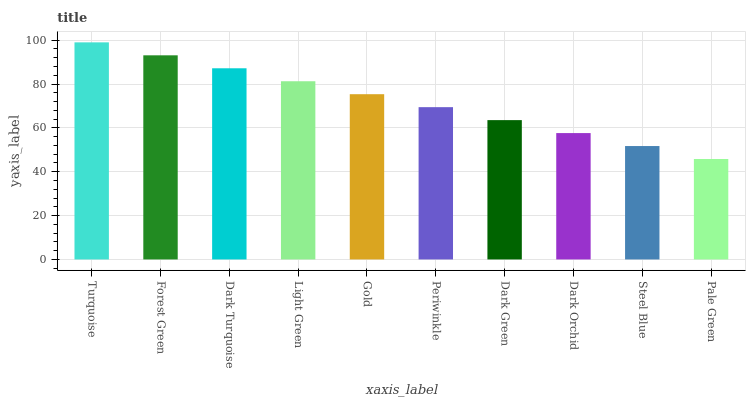Is Pale Green the minimum?
Answer yes or no. Yes. Is Turquoise the maximum?
Answer yes or no. Yes. Is Forest Green the minimum?
Answer yes or no. No. Is Forest Green the maximum?
Answer yes or no. No. Is Turquoise greater than Forest Green?
Answer yes or no. Yes. Is Forest Green less than Turquoise?
Answer yes or no. Yes. Is Forest Green greater than Turquoise?
Answer yes or no. No. Is Turquoise less than Forest Green?
Answer yes or no. No. Is Gold the high median?
Answer yes or no. Yes. Is Periwinkle the low median?
Answer yes or no. Yes. Is Light Green the high median?
Answer yes or no. No. Is Turquoise the low median?
Answer yes or no. No. 